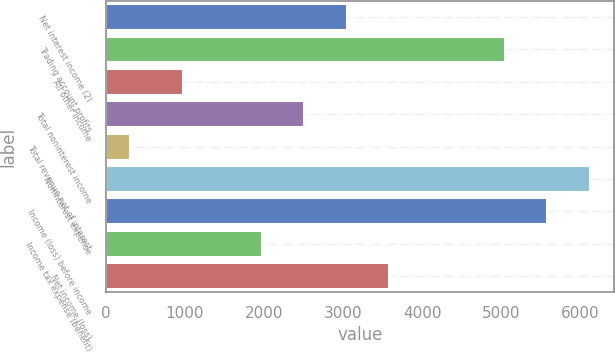Convert chart. <chart><loc_0><loc_0><loc_500><loc_500><bar_chart><fcel>Net interest income (2)<fcel>Trading account profits<fcel>All other income<fcel>Total noninterest income<fcel>Total revenue net of interest<fcel>Noninterest expense<fcel>Income (loss) before income<fcel>Income tax expense (benefit)<fcel>Net income (loss)<nl><fcel>3044.8<fcel>5050<fcel>971<fcel>2510.9<fcel>303<fcel>6117.8<fcel>5583.9<fcel>1977<fcel>3578.7<nl></chart> 